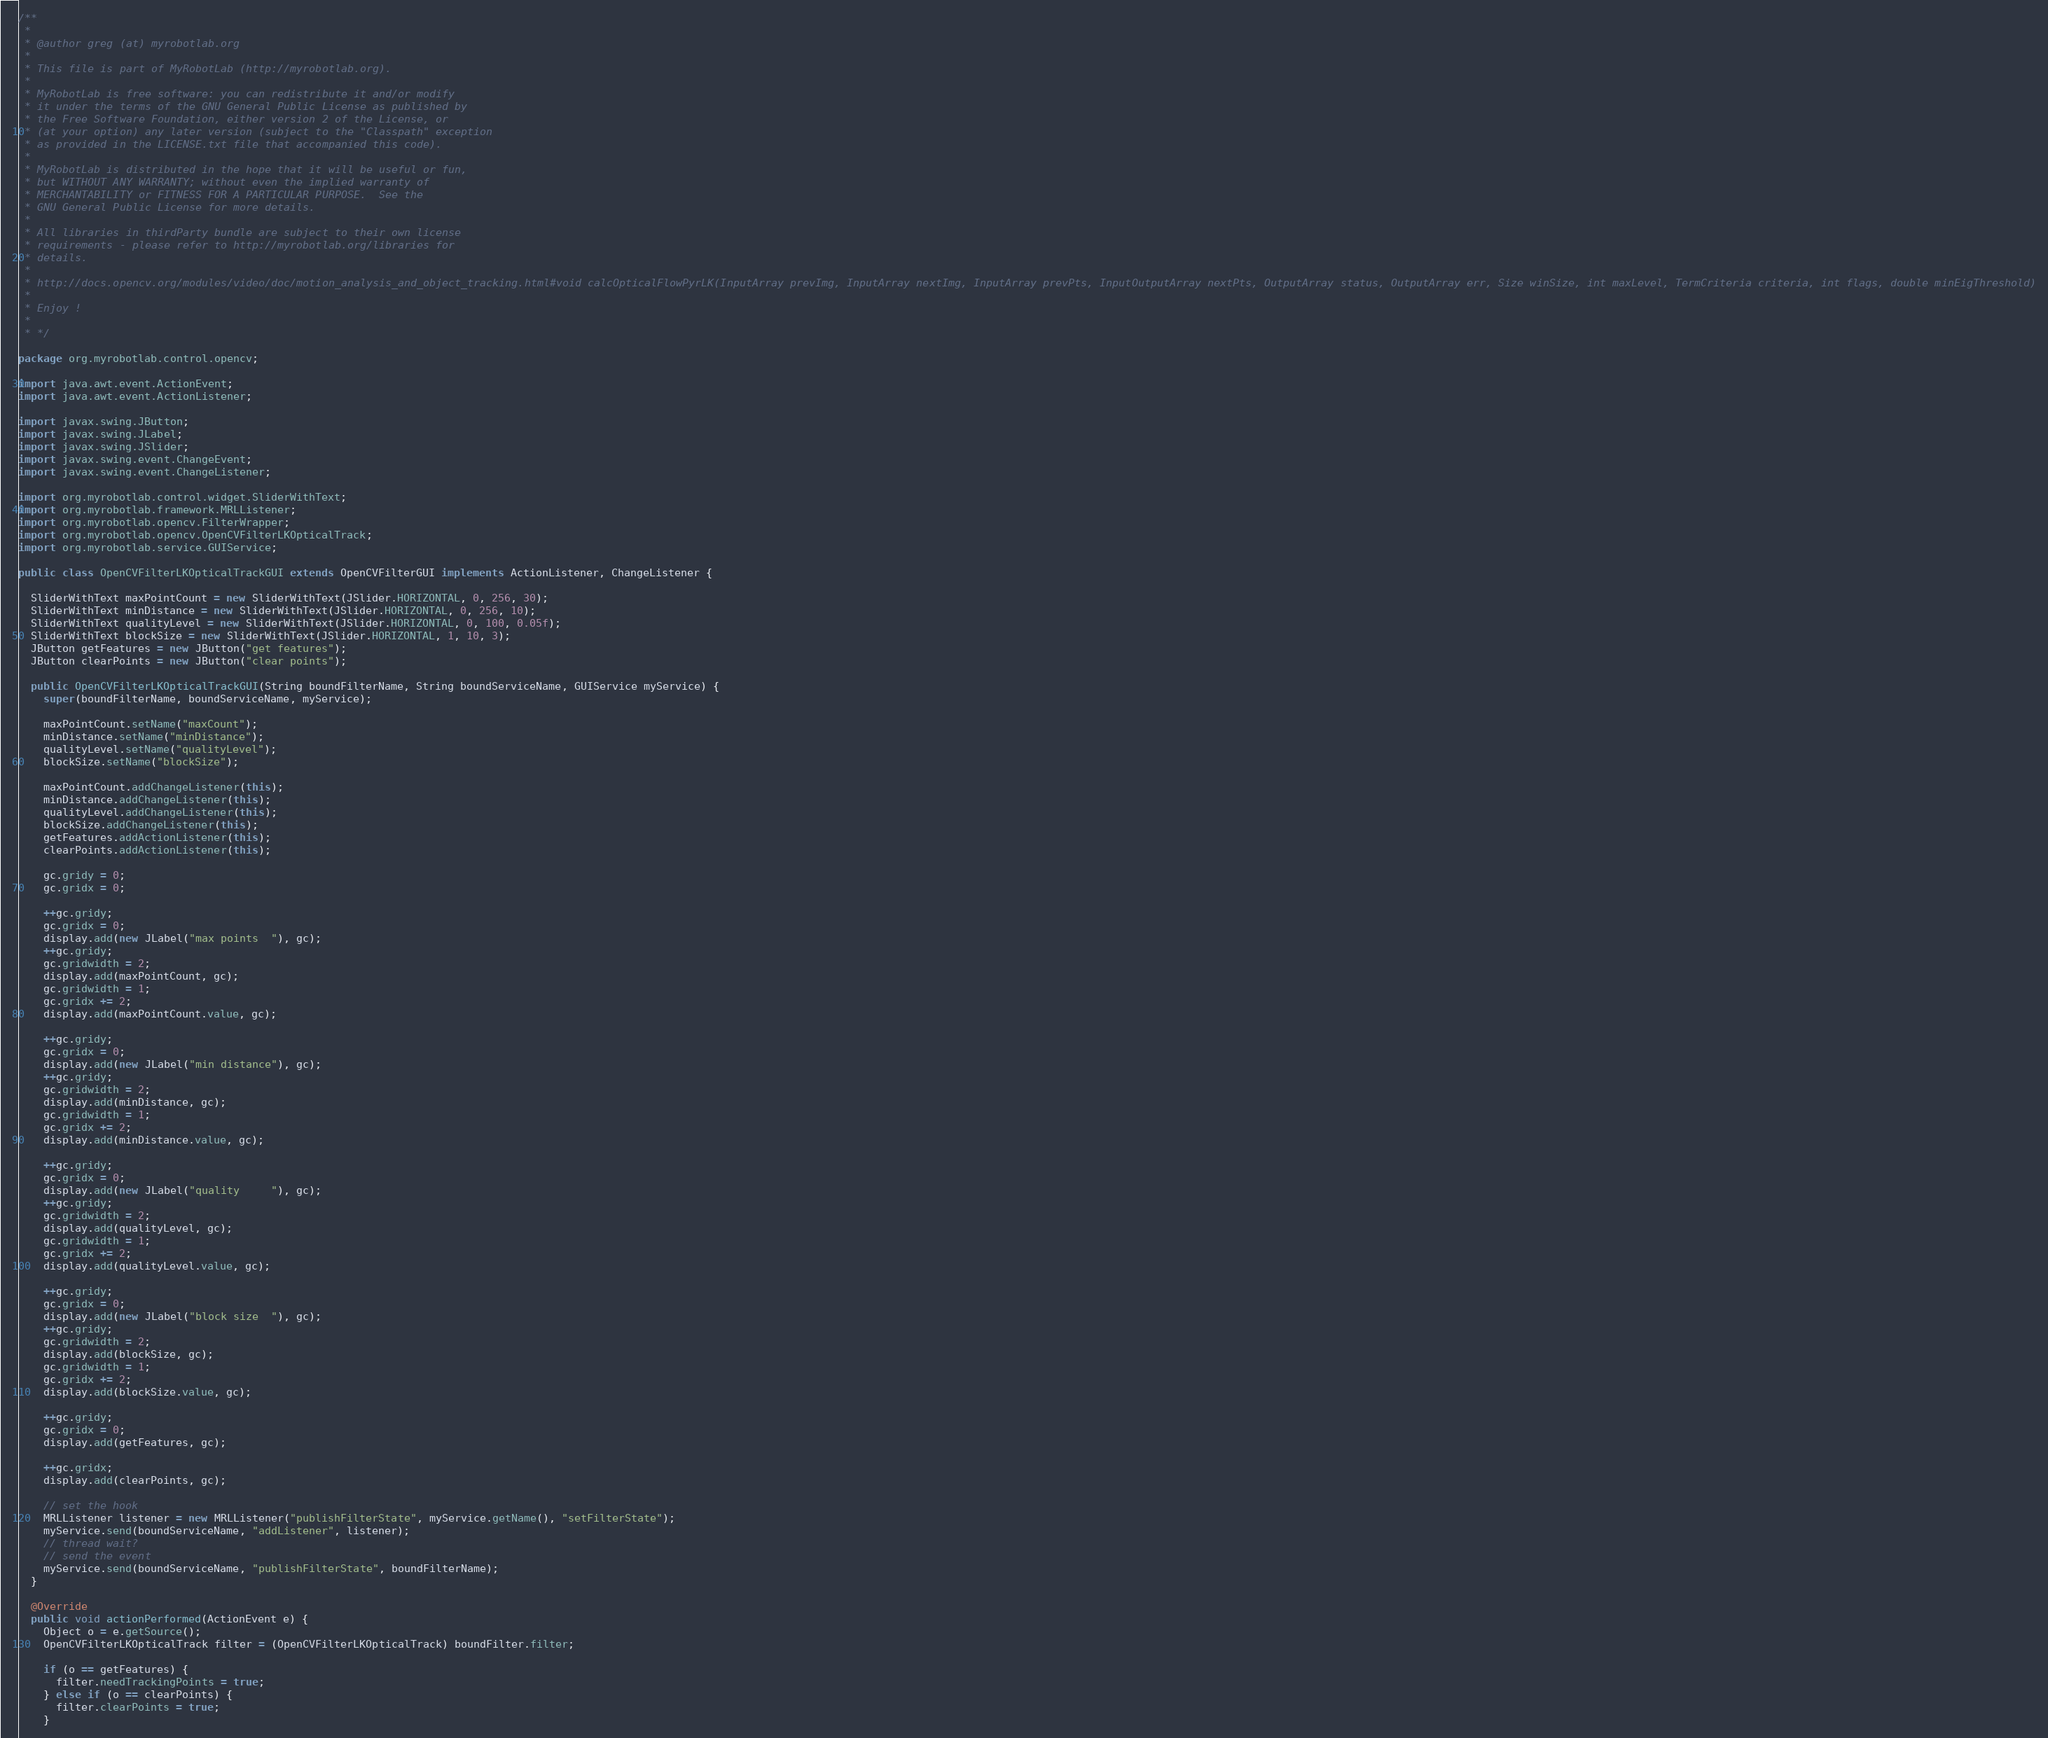Convert code to text. <code><loc_0><loc_0><loc_500><loc_500><_Java_>/**
 *                    
 * @author greg (at) myrobotlab.org
 *  
 * This file is part of MyRobotLab (http://myrobotlab.org).
 *
 * MyRobotLab is free software: you can redistribute it and/or modify
 * it under the terms of the GNU General Public License as published by
 * the Free Software Foundation, either version 2 of the License, or
 * (at your option) any later version (subject to the "Classpath" exception
 * as provided in the LICENSE.txt file that accompanied this code).
 *
 * MyRobotLab is distributed in the hope that it will be useful or fun,
 * but WITHOUT ANY WARRANTY; without even the implied warranty of
 * MERCHANTABILITY or FITNESS FOR A PARTICULAR PURPOSE.  See the
 * GNU General Public License for more details.
 *
 * All libraries in thirdParty bundle are subject to their own license
 * requirements - please refer to http://myrobotlab.org/libraries for 
 * details.
 * 
 * http://docs.opencv.org/modules/video/doc/motion_analysis_and_object_tracking.html#void calcOpticalFlowPyrLK(InputArray prevImg, InputArray nextImg, InputArray prevPts, InputOutputArray nextPts, OutputArray status, OutputArray err, Size winSize, int maxLevel, TermCriteria criteria, int flags, double minEigThreshold)
 * 
 * Enjoy !
 * 
 * */

package org.myrobotlab.control.opencv;

import java.awt.event.ActionEvent;
import java.awt.event.ActionListener;

import javax.swing.JButton;
import javax.swing.JLabel;
import javax.swing.JSlider;
import javax.swing.event.ChangeEvent;
import javax.swing.event.ChangeListener;

import org.myrobotlab.control.widget.SliderWithText;
import org.myrobotlab.framework.MRLListener;
import org.myrobotlab.opencv.FilterWrapper;
import org.myrobotlab.opencv.OpenCVFilterLKOpticalTrack;
import org.myrobotlab.service.GUIService;

public class OpenCVFilterLKOpticalTrackGUI extends OpenCVFilterGUI implements ActionListener, ChangeListener {

  SliderWithText maxPointCount = new SliderWithText(JSlider.HORIZONTAL, 0, 256, 30);
  SliderWithText minDistance = new SliderWithText(JSlider.HORIZONTAL, 0, 256, 10);
  SliderWithText qualityLevel = new SliderWithText(JSlider.HORIZONTAL, 0, 100, 0.05f);
  SliderWithText blockSize = new SliderWithText(JSlider.HORIZONTAL, 1, 10, 3);
  JButton getFeatures = new JButton("get features");
  JButton clearPoints = new JButton("clear points");

  public OpenCVFilterLKOpticalTrackGUI(String boundFilterName, String boundServiceName, GUIService myService) {
    super(boundFilterName, boundServiceName, myService);

    maxPointCount.setName("maxCount");
    minDistance.setName("minDistance");
    qualityLevel.setName("qualityLevel");
    blockSize.setName("blockSize");

    maxPointCount.addChangeListener(this);
    minDistance.addChangeListener(this);
    qualityLevel.addChangeListener(this);
    blockSize.addChangeListener(this);
    getFeatures.addActionListener(this);
    clearPoints.addActionListener(this);

    gc.gridy = 0;
    gc.gridx = 0;

    ++gc.gridy;
    gc.gridx = 0;
    display.add(new JLabel("max points  "), gc);
    ++gc.gridy;
    gc.gridwidth = 2;
    display.add(maxPointCount, gc);
    gc.gridwidth = 1;
    gc.gridx += 2;
    display.add(maxPointCount.value, gc);

    ++gc.gridy;
    gc.gridx = 0;
    display.add(new JLabel("min distance"), gc);
    ++gc.gridy;
    gc.gridwidth = 2;
    display.add(minDistance, gc);
    gc.gridwidth = 1;
    gc.gridx += 2;
    display.add(minDistance.value, gc);

    ++gc.gridy;
    gc.gridx = 0;
    display.add(new JLabel("quality     "), gc);
    ++gc.gridy;
    gc.gridwidth = 2;
    display.add(qualityLevel, gc);
    gc.gridwidth = 1;
    gc.gridx += 2;
    display.add(qualityLevel.value, gc);

    ++gc.gridy;
    gc.gridx = 0;
    display.add(new JLabel("block size  "), gc);
    ++gc.gridy;
    gc.gridwidth = 2;
    display.add(blockSize, gc);
    gc.gridwidth = 1;
    gc.gridx += 2;
    display.add(blockSize.value, gc);

    ++gc.gridy;
    gc.gridx = 0;
    display.add(getFeatures, gc);

    ++gc.gridx;
    display.add(clearPoints, gc);

    // set the hook
    MRLListener listener = new MRLListener("publishFilterState", myService.getName(), "setFilterState");
    myService.send(boundServiceName, "addListener", listener);
    // thread wait?
    // send the event
    myService.send(boundServiceName, "publishFilterState", boundFilterName);
  }

  @Override
  public void actionPerformed(ActionEvent e) {
    Object o = e.getSource();
    OpenCVFilterLKOpticalTrack filter = (OpenCVFilterLKOpticalTrack) boundFilter.filter;

    if (o == getFeatures) {
      filter.needTrackingPoints = true;
    } else if (o == clearPoints) {
      filter.clearPoints = true;
    }
</code> 